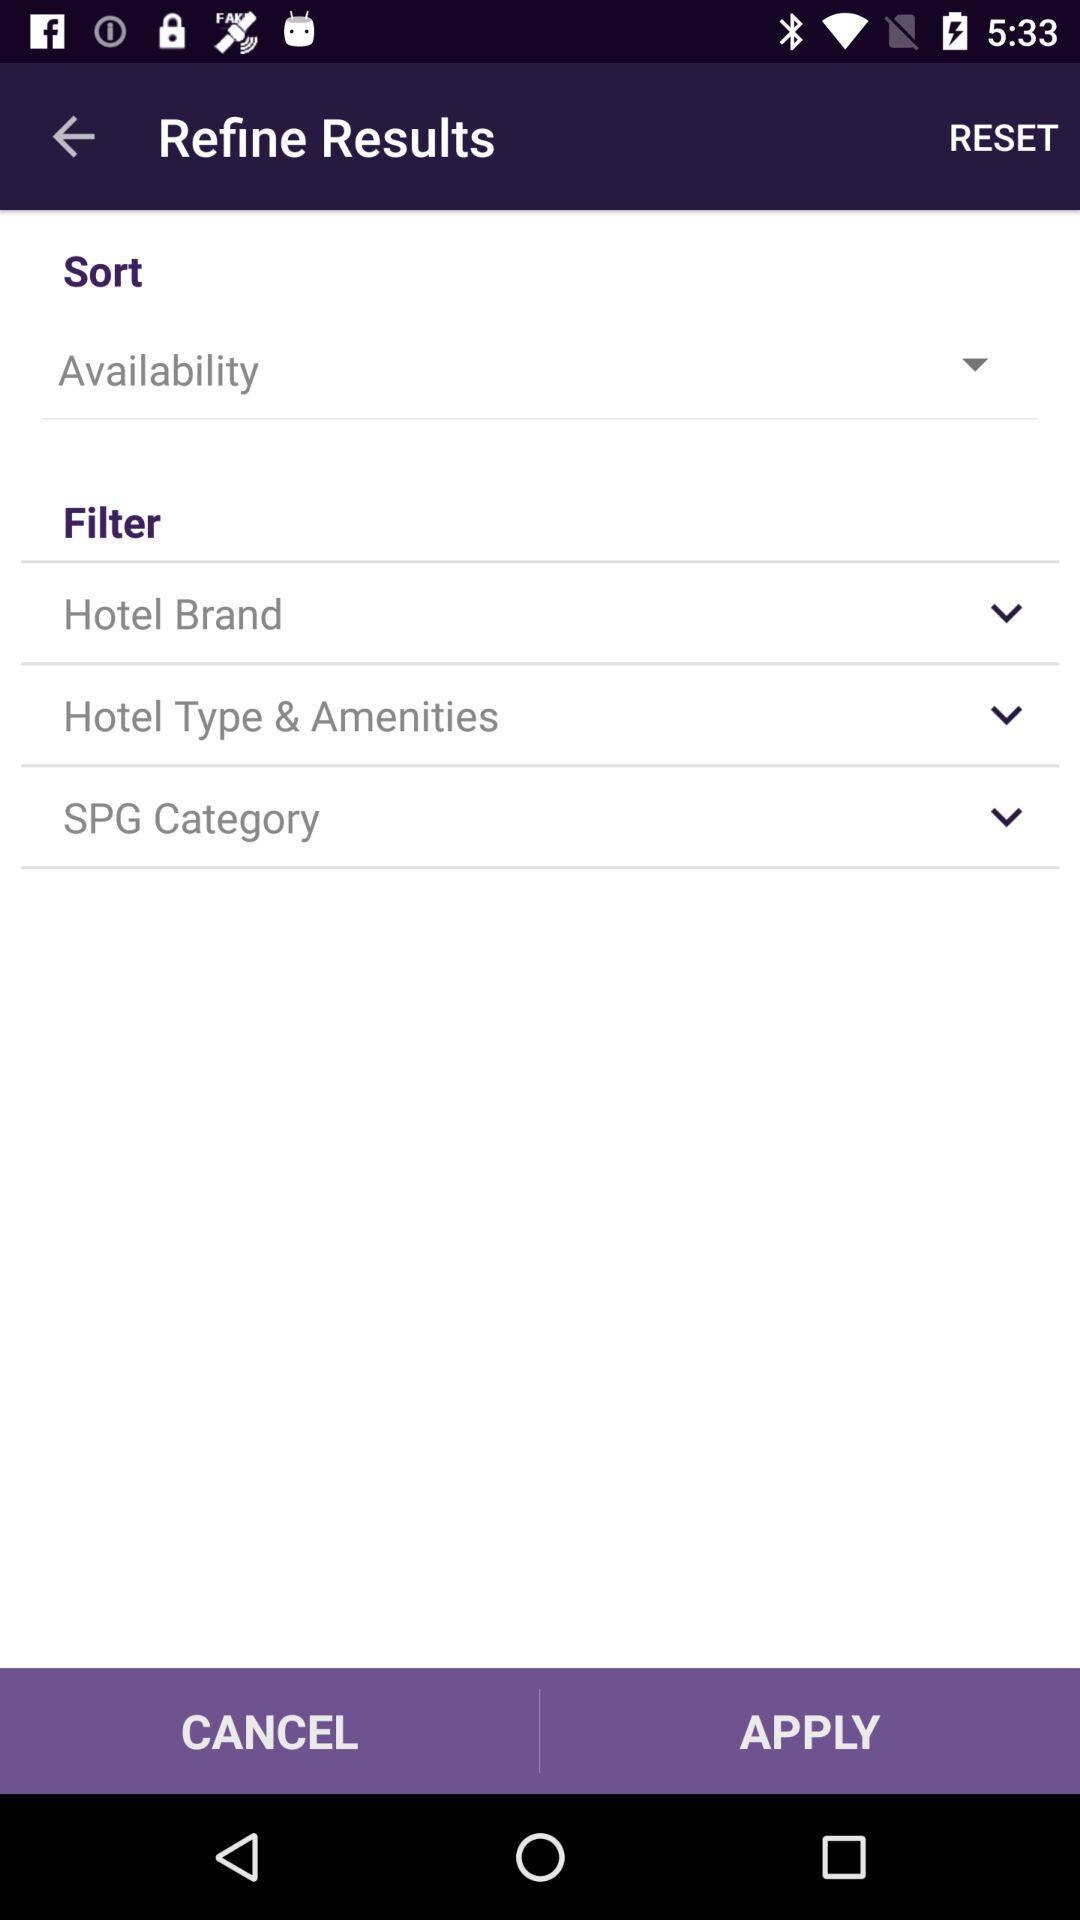What categories are in the filter option? The categories are "Hotel Brand", "Hotel Type & Amenities" and "SPG Category". 